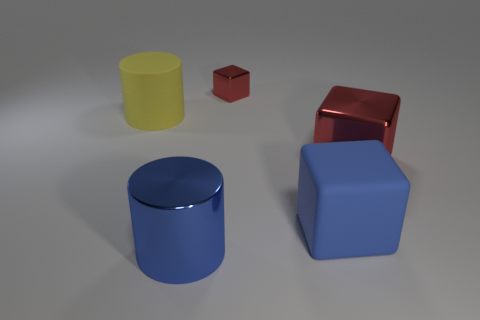How many red cubes must be subtracted to get 1 red cubes? 1 Add 5 blocks. How many objects exist? 10 Subtract all cylinders. How many objects are left? 3 Subtract all large matte blocks. Subtract all blue metal blocks. How many objects are left? 4 Add 4 metallic cubes. How many metallic cubes are left? 6 Add 3 blue objects. How many blue objects exist? 5 Subtract 0 brown spheres. How many objects are left? 5 